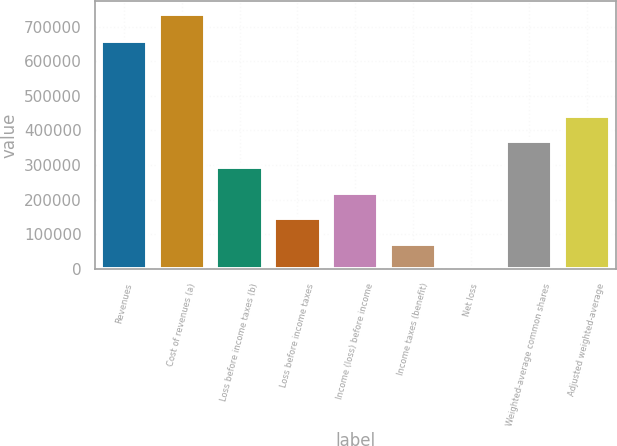Convert chart to OTSL. <chart><loc_0><loc_0><loc_500><loc_500><bar_chart><fcel>Revenues<fcel>Cost of revenues (a)<fcel>Loss before income taxes (b)<fcel>Loss before income taxes<fcel>Income (loss) before income<fcel>Income taxes (benefit)<fcel>Net loss<fcel>Weighted-average common shares<fcel>Adjusted weighted-average<nl><fcel>657882<fcel>736255<fcel>294502<fcel>147252<fcel>220877<fcel>73626.2<fcel>0.74<fcel>368128<fcel>441753<nl></chart> 